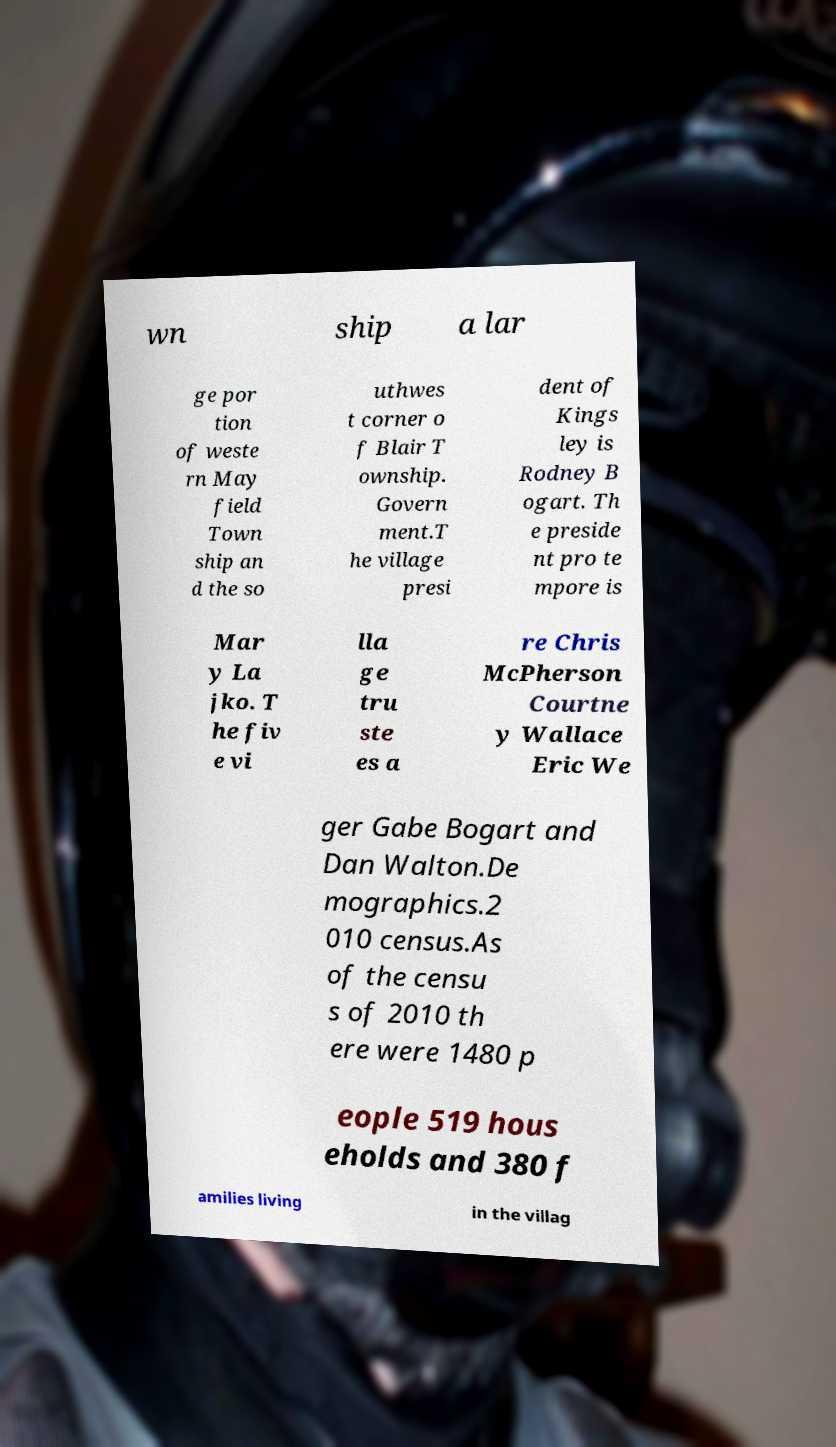Could you extract and type out the text from this image? wn ship a lar ge por tion of weste rn May field Town ship an d the so uthwes t corner o f Blair T ownship. Govern ment.T he village presi dent of Kings ley is Rodney B ogart. Th e preside nt pro te mpore is Mar y La jko. T he fiv e vi lla ge tru ste es a re Chris McPherson Courtne y Wallace Eric We ger Gabe Bogart and Dan Walton.De mographics.2 010 census.As of the censu s of 2010 th ere were 1480 p eople 519 hous eholds and 380 f amilies living in the villag 